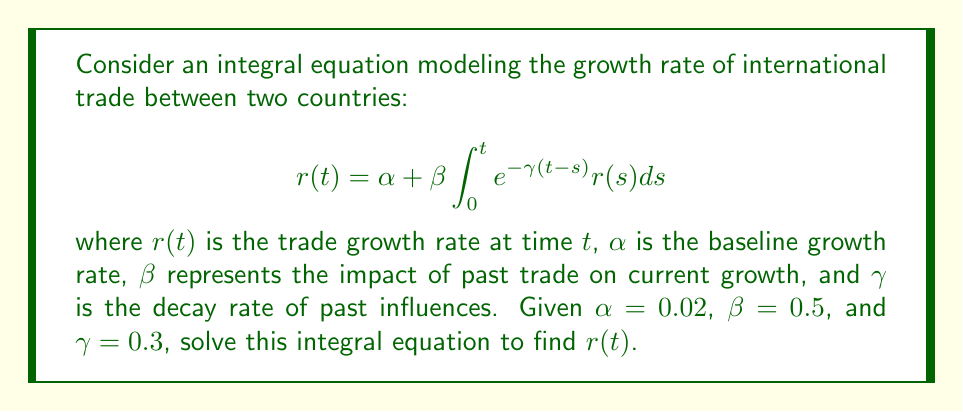Show me your answer to this math problem. To solve this integral equation, we'll follow these steps:

1) First, we differentiate both sides of the equation with respect to $t$:

   $$\frac{dr}{dt} = \beta e^{-\gamma t} \cdot r(t) + \beta \int_0^t e^{-\gamma(t-s)} r(s) \cdot (-\gamma) ds$$

2) Simplify using the original equation:

   $$\frac{dr}{dt} = \beta e^{-\gamma t} \cdot r(t) - \gamma (r(t) - \alpha)$$

3) Rearrange the terms:

   $$\frac{dr}{dt} + (\gamma - \beta e^{-\gamma t})r(t) = \gamma \alpha$$

4) This is a first-order linear differential equation. The integrating factor is:

   $$\mu(t) = \exp\left(\int (\gamma - \beta e^{-\gamma t}) dt\right) = \exp(\gamma t + \frac{\beta}{\gamma}e^{-\gamma t})$$

5) Multiply both sides by $\mu(t)$ and integrate:

   $$r(t) \cdot \mu(t) = \gamma \alpha \int \mu(t) dt + C$$

6) Solving for $r(t)$:

   $$r(t) = \frac{\gamma \alpha \int \mu(t) dt + C}{\mu(t)}$$

7) Apply the initial condition $r(0) = \alpha$ to find $C$:

   $$C = \alpha - \gamma \alpha \int_0^0 \mu(s) ds = \alpha$$

8) Therefore, the solution is:

   $$r(t) = \alpha + \frac{\gamma \alpha \int_0^t \exp(\gamma s + \frac{\beta}{\gamma}e^{-\gamma s}) ds}{\exp(\gamma t + \frac{\beta}{\gamma}e^{-\gamma t})}$$

9) Substituting the given values $\alpha = 0.02$, $\beta = 0.5$, and $\gamma = 0.3$:

   $$r(t) = 0.02 + \frac{0.006 \int_0^t \exp(0.3s + \frac{5}{3}e^{-0.3s}) ds}{\exp(0.3t + \frac{5}{3}e^{-0.3t})}$$
Answer: $$r(t) = 0.02 + \frac{0.006 \int_0^t \exp(0.3s + \frac{5}{3}e^{-0.3s}) ds}{\exp(0.3t + \frac{5}{3}e^{-0.3t})}$$ 